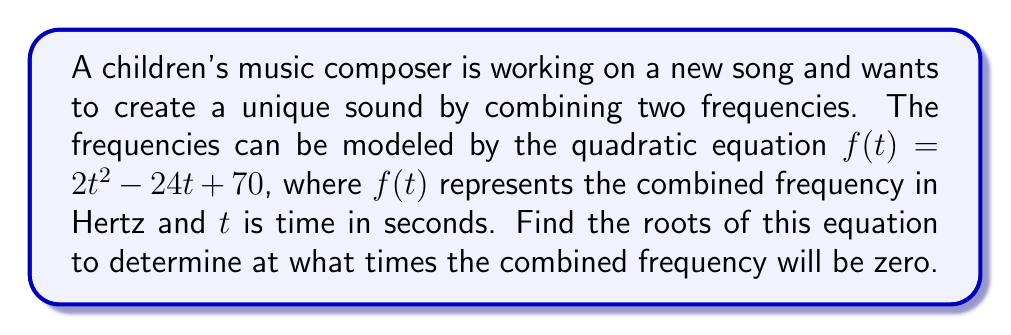Help me with this question. To find the roots of the quadratic equation, we'll use the quadratic formula:

$$x = \frac{-b \pm \sqrt{b^2 - 4ac}}{2a}$$

Where $a = 2$, $b = -24$, and $c = 70$

Step 1: Substitute the values into the quadratic formula:
$$t = \frac{-(-24) \pm \sqrt{(-24)^2 - 4(2)(70)}}{2(2)}$$

Step 2: Simplify under the square root:
$$t = \frac{24 \pm \sqrt{576 - 560}}{4}$$

Step 3: Calculate inside the square root:
$$t = \frac{24 \pm \sqrt{16}}{4}$$

Step 4: Simplify the square root:
$$t = \frac{24 \pm 4}{4}$$

Step 5: Calculate the two solutions:
$$t_1 = \frac{24 + 4}{4} = \frac{28}{4} = 7$$
$$t_2 = \frac{24 - 4}{4} = \frac{20}{4} = 5$$

Therefore, the combined frequency will be zero at $t = 5$ seconds and $t = 7$ seconds.
Answer: $t = 5$ and $t = 7$ 